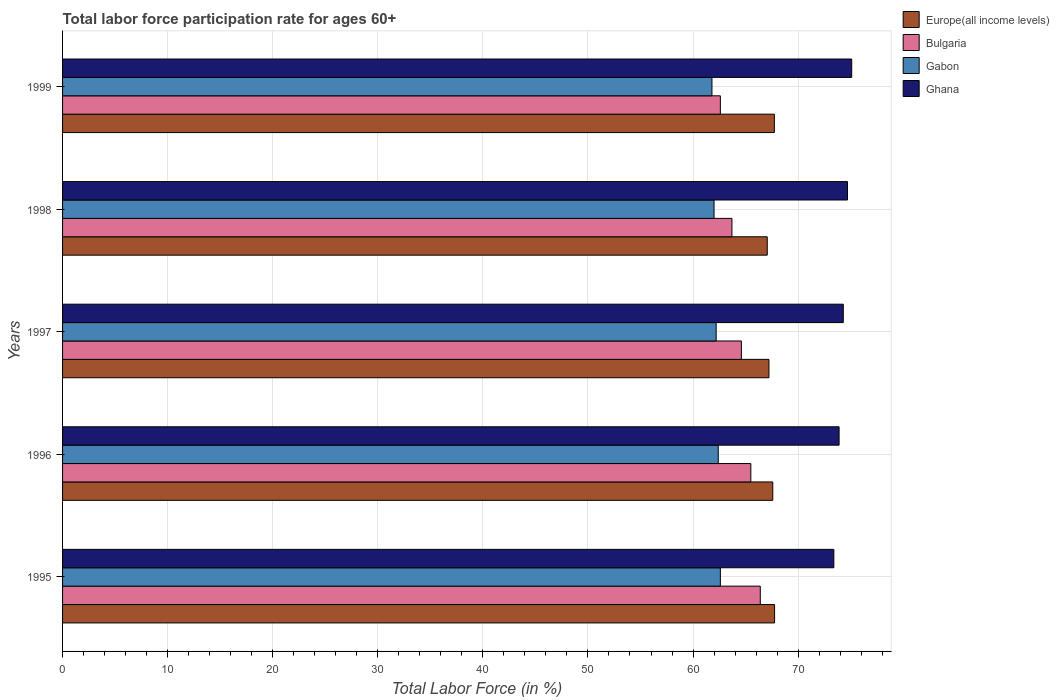How many different coloured bars are there?
Provide a succinct answer. 4. How many groups of bars are there?
Ensure brevity in your answer.  5. Are the number of bars per tick equal to the number of legend labels?
Your answer should be very brief. Yes. Are the number of bars on each tick of the Y-axis equal?
Provide a short and direct response. Yes. How many bars are there on the 2nd tick from the top?
Your response must be concise. 4. What is the labor force participation rate in Bulgaria in 1997?
Provide a short and direct response. 64.6. Across all years, what is the maximum labor force participation rate in Ghana?
Give a very brief answer. 75.1. Across all years, what is the minimum labor force participation rate in Gabon?
Provide a short and direct response. 61.8. What is the total labor force participation rate in Gabon in the graph?
Your answer should be compact. 311. What is the difference between the labor force participation rate in Ghana in 1997 and that in 1998?
Your answer should be very brief. -0.4. What is the difference between the labor force participation rate in Ghana in 1997 and the labor force participation rate in Bulgaria in 1999?
Your response must be concise. 11.7. What is the average labor force participation rate in Ghana per year?
Offer a terse response. 74.28. In the year 1999, what is the difference between the labor force participation rate in Europe(all income levels) and labor force participation rate in Ghana?
Give a very brief answer. -7.36. What is the ratio of the labor force participation rate in Bulgaria in 1995 to that in 1998?
Provide a short and direct response. 1.04. Is the labor force participation rate in Ghana in 1998 less than that in 1999?
Offer a terse response. Yes. Is the difference between the labor force participation rate in Europe(all income levels) in 1996 and 1998 greater than the difference between the labor force participation rate in Ghana in 1996 and 1998?
Provide a succinct answer. Yes. What is the difference between the highest and the second highest labor force participation rate in Europe(all income levels)?
Your response must be concise. 0.02. What is the difference between the highest and the lowest labor force participation rate in Gabon?
Keep it short and to the point. 0.8. In how many years, is the labor force participation rate in Ghana greater than the average labor force participation rate in Ghana taken over all years?
Ensure brevity in your answer.  3. Is it the case that in every year, the sum of the labor force participation rate in Ghana and labor force participation rate in Gabon is greater than the sum of labor force participation rate in Bulgaria and labor force participation rate in Europe(all income levels)?
Your answer should be very brief. No. What does the 1st bar from the top in 1997 represents?
Provide a short and direct response. Ghana. What does the 1st bar from the bottom in 1995 represents?
Keep it short and to the point. Europe(all income levels). Is it the case that in every year, the sum of the labor force participation rate in Ghana and labor force participation rate in Europe(all income levels) is greater than the labor force participation rate in Gabon?
Your answer should be compact. Yes. How many bars are there?
Provide a short and direct response. 20. Are all the bars in the graph horizontal?
Give a very brief answer. Yes. How many years are there in the graph?
Provide a succinct answer. 5. What is the difference between two consecutive major ticks on the X-axis?
Give a very brief answer. 10. Does the graph contain any zero values?
Make the answer very short. No. Does the graph contain grids?
Offer a terse response. Yes. Where does the legend appear in the graph?
Give a very brief answer. Top right. What is the title of the graph?
Offer a terse response. Total labor force participation rate for ages 60+. What is the label or title of the Y-axis?
Offer a terse response. Years. What is the Total Labor Force (in %) of Europe(all income levels) in 1995?
Keep it short and to the point. 67.76. What is the Total Labor Force (in %) in Bulgaria in 1995?
Keep it short and to the point. 66.4. What is the Total Labor Force (in %) of Gabon in 1995?
Your answer should be compact. 62.6. What is the Total Labor Force (in %) of Ghana in 1995?
Provide a succinct answer. 73.4. What is the Total Labor Force (in %) in Europe(all income levels) in 1996?
Provide a succinct answer. 67.59. What is the Total Labor Force (in %) of Bulgaria in 1996?
Your answer should be very brief. 65.5. What is the Total Labor Force (in %) in Gabon in 1996?
Ensure brevity in your answer.  62.4. What is the Total Labor Force (in %) in Ghana in 1996?
Provide a succinct answer. 73.9. What is the Total Labor Force (in %) of Europe(all income levels) in 1997?
Keep it short and to the point. 67.22. What is the Total Labor Force (in %) in Bulgaria in 1997?
Provide a short and direct response. 64.6. What is the Total Labor Force (in %) of Gabon in 1997?
Offer a very short reply. 62.2. What is the Total Labor Force (in %) in Ghana in 1997?
Provide a short and direct response. 74.3. What is the Total Labor Force (in %) of Europe(all income levels) in 1998?
Your response must be concise. 67.06. What is the Total Labor Force (in %) of Bulgaria in 1998?
Ensure brevity in your answer.  63.7. What is the Total Labor Force (in %) of Ghana in 1998?
Your response must be concise. 74.7. What is the Total Labor Force (in %) in Europe(all income levels) in 1999?
Provide a succinct answer. 67.74. What is the Total Labor Force (in %) of Bulgaria in 1999?
Keep it short and to the point. 62.6. What is the Total Labor Force (in %) of Gabon in 1999?
Offer a very short reply. 61.8. What is the Total Labor Force (in %) of Ghana in 1999?
Provide a short and direct response. 75.1. Across all years, what is the maximum Total Labor Force (in %) of Europe(all income levels)?
Your answer should be compact. 67.76. Across all years, what is the maximum Total Labor Force (in %) in Bulgaria?
Provide a succinct answer. 66.4. Across all years, what is the maximum Total Labor Force (in %) in Gabon?
Provide a succinct answer. 62.6. Across all years, what is the maximum Total Labor Force (in %) of Ghana?
Keep it short and to the point. 75.1. Across all years, what is the minimum Total Labor Force (in %) of Europe(all income levels)?
Give a very brief answer. 67.06. Across all years, what is the minimum Total Labor Force (in %) in Bulgaria?
Keep it short and to the point. 62.6. Across all years, what is the minimum Total Labor Force (in %) in Gabon?
Your answer should be very brief. 61.8. Across all years, what is the minimum Total Labor Force (in %) in Ghana?
Give a very brief answer. 73.4. What is the total Total Labor Force (in %) in Europe(all income levels) in the graph?
Your answer should be very brief. 337.38. What is the total Total Labor Force (in %) of Bulgaria in the graph?
Ensure brevity in your answer.  322.8. What is the total Total Labor Force (in %) in Gabon in the graph?
Give a very brief answer. 311. What is the total Total Labor Force (in %) of Ghana in the graph?
Provide a short and direct response. 371.4. What is the difference between the Total Labor Force (in %) of Europe(all income levels) in 1995 and that in 1996?
Keep it short and to the point. 0.17. What is the difference between the Total Labor Force (in %) of Bulgaria in 1995 and that in 1996?
Make the answer very short. 0.9. What is the difference between the Total Labor Force (in %) of Europe(all income levels) in 1995 and that in 1997?
Your response must be concise. 0.54. What is the difference between the Total Labor Force (in %) of Gabon in 1995 and that in 1997?
Offer a terse response. 0.4. What is the difference between the Total Labor Force (in %) of Ghana in 1995 and that in 1997?
Your answer should be very brief. -0.9. What is the difference between the Total Labor Force (in %) of Europe(all income levels) in 1995 and that in 1998?
Provide a succinct answer. 0.7. What is the difference between the Total Labor Force (in %) of Gabon in 1995 and that in 1998?
Offer a very short reply. 0.6. What is the difference between the Total Labor Force (in %) of Europe(all income levels) in 1995 and that in 1999?
Your response must be concise. 0.02. What is the difference between the Total Labor Force (in %) of Europe(all income levels) in 1996 and that in 1997?
Keep it short and to the point. 0.36. What is the difference between the Total Labor Force (in %) in Bulgaria in 1996 and that in 1997?
Ensure brevity in your answer.  0.9. What is the difference between the Total Labor Force (in %) in Gabon in 1996 and that in 1997?
Give a very brief answer. 0.2. What is the difference between the Total Labor Force (in %) of Ghana in 1996 and that in 1997?
Your response must be concise. -0.4. What is the difference between the Total Labor Force (in %) of Europe(all income levels) in 1996 and that in 1998?
Offer a terse response. 0.53. What is the difference between the Total Labor Force (in %) in Europe(all income levels) in 1996 and that in 1999?
Give a very brief answer. -0.15. What is the difference between the Total Labor Force (in %) in Ghana in 1996 and that in 1999?
Offer a terse response. -1.2. What is the difference between the Total Labor Force (in %) in Europe(all income levels) in 1997 and that in 1998?
Offer a terse response. 0.16. What is the difference between the Total Labor Force (in %) of Bulgaria in 1997 and that in 1998?
Offer a very short reply. 0.9. What is the difference between the Total Labor Force (in %) of Ghana in 1997 and that in 1998?
Your answer should be compact. -0.4. What is the difference between the Total Labor Force (in %) in Europe(all income levels) in 1997 and that in 1999?
Provide a succinct answer. -0.52. What is the difference between the Total Labor Force (in %) in Bulgaria in 1997 and that in 1999?
Offer a terse response. 2. What is the difference between the Total Labor Force (in %) of Europe(all income levels) in 1998 and that in 1999?
Offer a terse response. -0.68. What is the difference between the Total Labor Force (in %) of Bulgaria in 1998 and that in 1999?
Your response must be concise. 1.1. What is the difference between the Total Labor Force (in %) in Gabon in 1998 and that in 1999?
Your response must be concise. 0.2. What is the difference between the Total Labor Force (in %) of Europe(all income levels) in 1995 and the Total Labor Force (in %) of Bulgaria in 1996?
Provide a short and direct response. 2.26. What is the difference between the Total Labor Force (in %) in Europe(all income levels) in 1995 and the Total Labor Force (in %) in Gabon in 1996?
Provide a succinct answer. 5.36. What is the difference between the Total Labor Force (in %) in Europe(all income levels) in 1995 and the Total Labor Force (in %) in Ghana in 1996?
Your answer should be very brief. -6.14. What is the difference between the Total Labor Force (in %) of Bulgaria in 1995 and the Total Labor Force (in %) of Gabon in 1996?
Offer a very short reply. 4. What is the difference between the Total Labor Force (in %) in Gabon in 1995 and the Total Labor Force (in %) in Ghana in 1996?
Provide a succinct answer. -11.3. What is the difference between the Total Labor Force (in %) in Europe(all income levels) in 1995 and the Total Labor Force (in %) in Bulgaria in 1997?
Keep it short and to the point. 3.16. What is the difference between the Total Labor Force (in %) of Europe(all income levels) in 1995 and the Total Labor Force (in %) of Gabon in 1997?
Ensure brevity in your answer.  5.56. What is the difference between the Total Labor Force (in %) in Europe(all income levels) in 1995 and the Total Labor Force (in %) in Ghana in 1997?
Your answer should be compact. -6.54. What is the difference between the Total Labor Force (in %) in Gabon in 1995 and the Total Labor Force (in %) in Ghana in 1997?
Your response must be concise. -11.7. What is the difference between the Total Labor Force (in %) of Europe(all income levels) in 1995 and the Total Labor Force (in %) of Bulgaria in 1998?
Your answer should be very brief. 4.06. What is the difference between the Total Labor Force (in %) of Europe(all income levels) in 1995 and the Total Labor Force (in %) of Gabon in 1998?
Your response must be concise. 5.76. What is the difference between the Total Labor Force (in %) of Europe(all income levels) in 1995 and the Total Labor Force (in %) of Ghana in 1998?
Offer a very short reply. -6.94. What is the difference between the Total Labor Force (in %) of Bulgaria in 1995 and the Total Labor Force (in %) of Gabon in 1998?
Make the answer very short. 4.4. What is the difference between the Total Labor Force (in %) in Bulgaria in 1995 and the Total Labor Force (in %) in Ghana in 1998?
Your answer should be very brief. -8.3. What is the difference between the Total Labor Force (in %) of Europe(all income levels) in 1995 and the Total Labor Force (in %) of Bulgaria in 1999?
Provide a succinct answer. 5.16. What is the difference between the Total Labor Force (in %) in Europe(all income levels) in 1995 and the Total Labor Force (in %) in Gabon in 1999?
Your response must be concise. 5.96. What is the difference between the Total Labor Force (in %) of Europe(all income levels) in 1995 and the Total Labor Force (in %) of Ghana in 1999?
Provide a short and direct response. -7.34. What is the difference between the Total Labor Force (in %) of Bulgaria in 1995 and the Total Labor Force (in %) of Ghana in 1999?
Your answer should be very brief. -8.7. What is the difference between the Total Labor Force (in %) in Gabon in 1995 and the Total Labor Force (in %) in Ghana in 1999?
Offer a very short reply. -12.5. What is the difference between the Total Labor Force (in %) in Europe(all income levels) in 1996 and the Total Labor Force (in %) in Bulgaria in 1997?
Your response must be concise. 2.99. What is the difference between the Total Labor Force (in %) in Europe(all income levels) in 1996 and the Total Labor Force (in %) in Gabon in 1997?
Provide a succinct answer. 5.39. What is the difference between the Total Labor Force (in %) of Europe(all income levels) in 1996 and the Total Labor Force (in %) of Ghana in 1997?
Ensure brevity in your answer.  -6.71. What is the difference between the Total Labor Force (in %) in Bulgaria in 1996 and the Total Labor Force (in %) in Ghana in 1997?
Give a very brief answer. -8.8. What is the difference between the Total Labor Force (in %) of Europe(all income levels) in 1996 and the Total Labor Force (in %) of Bulgaria in 1998?
Make the answer very short. 3.89. What is the difference between the Total Labor Force (in %) of Europe(all income levels) in 1996 and the Total Labor Force (in %) of Gabon in 1998?
Provide a succinct answer. 5.59. What is the difference between the Total Labor Force (in %) in Europe(all income levels) in 1996 and the Total Labor Force (in %) in Ghana in 1998?
Offer a very short reply. -7.11. What is the difference between the Total Labor Force (in %) in Bulgaria in 1996 and the Total Labor Force (in %) in Ghana in 1998?
Give a very brief answer. -9.2. What is the difference between the Total Labor Force (in %) in Europe(all income levels) in 1996 and the Total Labor Force (in %) in Bulgaria in 1999?
Your answer should be compact. 4.99. What is the difference between the Total Labor Force (in %) of Europe(all income levels) in 1996 and the Total Labor Force (in %) of Gabon in 1999?
Ensure brevity in your answer.  5.79. What is the difference between the Total Labor Force (in %) in Europe(all income levels) in 1996 and the Total Labor Force (in %) in Ghana in 1999?
Give a very brief answer. -7.51. What is the difference between the Total Labor Force (in %) in Bulgaria in 1996 and the Total Labor Force (in %) in Gabon in 1999?
Offer a terse response. 3.7. What is the difference between the Total Labor Force (in %) in Europe(all income levels) in 1997 and the Total Labor Force (in %) in Bulgaria in 1998?
Your answer should be very brief. 3.52. What is the difference between the Total Labor Force (in %) in Europe(all income levels) in 1997 and the Total Labor Force (in %) in Gabon in 1998?
Provide a succinct answer. 5.22. What is the difference between the Total Labor Force (in %) in Europe(all income levels) in 1997 and the Total Labor Force (in %) in Ghana in 1998?
Your answer should be very brief. -7.48. What is the difference between the Total Labor Force (in %) in Bulgaria in 1997 and the Total Labor Force (in %) in Gabon in 1998?
Provide a short and direct response. 2.6. What is the difference between the Total Labor Force (in %) of Bulgaria in 1997 and the Total Labor Force (in %) of Ghana in 1998?
Make the answer very short. -10.1. What is the difference between the Total Labor Force (in %) of Gabon in 1997 and the Total Labor Force (in %) of Ghana in 1998?
Provide a short and direct response. -12.5. What is the difference between the Total Labor Force (in %) of Europe(all income levels) in 1997 and the Total Labor Force (in %) of Bulgaria in 1999?
Ensure brevity in your answer.  4.62. What is the difference between the Total Labor Force (in %) in Europe(all income levels) in 1997 and the Total Labor Force (in %) in Gabon in 1999?
Your response must be concise. 5.42. What is the difference between the Total Labor Force (in %) in Europe(all income levels) in 1997 and the Total Labor Force (in %) in Ghana in 1999?
Keep it short and to the point. -7.88. What is the difference between the Total Labor Force (in %) of Bulgaria in 1997 and the Total Labor Force (in %) of Gabon in 1999?
Make the answer very short. 2.8. What is the difference between the Total Labor Force (in %) of Bulgaria in 1997 and the Total Labor Force (in %) of Ghana in 1999?
Ensure brevity in your answer.  -10.5. What is the difference between the Total Labor Force (in %) in Europe(all income levels) in 1998 and the Total Labor Force (in %) in Bulgaria in 1999?
Provide a short and direct response. 4.46. What is the difference between the Total Labor Force (in %) in Europe(all income levels) in 1998 and the Total Labor Force (in %) in Gabon in 1999?
Keep it short and to the point. 5.26. What is the difference between the Total Labor Force (in %) of Europe(all income levels) in 1998 and the Total Labor Force (in %) of Ghana in 1999?
Make the answer very short. -8.04. What is the difference between the Total Labor Force (in %) of Bulgaria in 1998 and the Total Labor Force (in %) of Ghana in 1999?
Keep it short and to the point. -11.4. What is the difference between the Total Labor Force (in %) in Gabon in 1998 and the Total Labor Force (in %) in Ghana in 1999?
Provide a succinct answer. -13.1. What is the average Total Labor Force (in %) of Europe(all income levels) per year?
Keep it short and to the point. 67.48. What is the average Total Labor Force (in %) of Bulgaria per year?
Your answer should be very brief. 64.56. What is the average Total Labor Force (in %) in Gabon per year?
Provide a succinct answer. 62.2. What is the average Total Labor Force (in %) of Ghana per year?
Your response must be concise. 74.28. In the year 1995, what is the difference between the Total Labor Force (in %) in Europe(all income levels) and Total Labor Force (in %) in Bulgaria?
Offer a very short reply. 1.36. In the year 1995, what is the difference between the Total Labor Force (in %) of Europe(all income levels) and Total Labor Force (in %) of Gabon?
Provide a short and direct response. 5.16. In the year 1995, what is the difference between the Total Labor Force (in %) of Europe(all income levels) and Total Labor Force (in %) of Ghana?
Offer a terse response. -5.64. In the year 1995, what is the difference between the Total Labor Force (in %) of Bulgaria and Total Labor Force (in %) of Gabon?
Your response must be concise. 3.8. In the year 1995, what is the difference between the Total Labor Force (in %) of Bulgaria and Total Labor Force (in %) of Ghana?
Provide a succinct answer. -7. In the year 1996, what is the difference between the Total Labor Force (in %) of Europe(all income levels) and Total Labor Force (in %) of Bulgaria?
Offer a terse response. 2.09. In the year 1996, what is the difference between the Total Labor Force (in %) in Europe(all income levels) and Total Labor Force (in %) in Gabon?
Provide a short and direct response. 5.19. In the year 1996, what is the difference between the Total Labor Force (in %) in Europe(all income levels) and Total Labor Force (in %) in Ghana?
Keep it short and to the point. -6.31. In the year 1996, what is the difference between the Total Labor Force (in %) in Bulgaria and Total Labor Force (in %) in Ghana?
Offer a terse response. -8.4. In the year 1996, what is the difference between the Total Labor Force (in %) in Gabon and Total Labor Force (in %) in Ghana?
Your answer should be very brief. -11.5. In the year 1997, what is the difference between the Total Labor Force (in %) of Europe(all income levels) and Total Labor Force (in %) of Bulgaria?
Provide a short and direct response. 2.62. In the year 1997, what is the difference between the Total Labor Force (in %) of Europe(all income levels) and Total Labor Force (in %) of Gabon?
Keep it short and to the point. 5.02. In the year 1997, what is the difference between the Total Labor Force (in %) of Europe(all income levels) and Total Labor Force (in %) of Ghana?
Provide a short and direct response. -7.08. In the year 1997, what is the difference between the Total Labor Force (in %) of Bulgaria and Total Labor Force (in %) of Gabon?
Offer a very short reply. 2.4. In the year 1998, what is the difference between the Total Labor Force (in %) of Europe(all income levels) and Total Labor Force (in %) of Bulgaria?
Your answer should be compact. 3.36. In the year 1998, what is the difference between the Total Labor Force (in %) in Europe(all income levels) and Total Labor Force (in %) in Gabon?
Keep it short and to the point. 5.06. In the year 1998, what is the difference between the Total Labor Force (in %) of Europe(all income levels) and Total Labor Force (in %) of Ghana?
Your answer should be very brief. -7.64. In the year 1998, what is the difference between the Total Labor Force (in %) of Bulgaria and Total Labor Force (in %) of Gabon?
Offer a terse response. 1.7. In the year 1998, what is the difference between the Total Labor Force (in %) in Bulgaria and Total Labor Force (in %) in Ghana?
Make the answer very short. -11. In the year 1998, what is the difference between the Total Labor Force (in %) in Gabon and Total Labor Force (in %) in Ghana?
Make the answer very short. -12.7. In the year 1999, what is the difference between the Total Labor Force (in %) of Europe(all income levels) and Total Labor Force (in %) of Bulgaria?
Provide a short and direct response. 5.14. In the year 1999, what is the difference between the Total Labor Force (in %) in Europe(all income levels) and Total Labor Force (in %) in Gabon?
Give a very brief answer. 5.94. In the year 1999, what is the difference between the Total Labor Force (in %) in Europe(all income levels) and Total Labor Force (in %) in Ghana?
Keep it short and to the point. -7.36. In the year 1999, what is the difference between the Total Labor Force (in %) in Bulgaria and Total Labor Force (in %) in Gabon?
Your answer should be compact. 0.8. In the year 1999, what is the difference between the Total Labor Force (in %) of Bulgaria and Total Labor Force (in %) of Ghana?
Offer a terse response. -12.5. In the year 1999, what is the difference between the Total Labor Force (in %) of Gabon and Total Labor Force (in %) of Ghana?
Offer a terse response. -13.3. What is the ratio of the Total Labor Force (in %) of Europe(all income levels) in 1995 to that in 1996?
Offer a terse response. 1. What is the ratio of the Total Labor Force (in %) of Bulgaria in 1995 to that in 1996?
Make the answer very short. 1.01. What is the ratio of the Total Labor Force (in %) in Ghana in 1995 to that in 1996?
Keep it short and to the point. 0.99. What is the ratio of the Total Labor Force (in %) in Europe(all income levels) in 1995 to that in 1997?
Your response must be concise. 1.01. What is the ratio of the Total Labor Force (in %) of Bulgaria in 1995 to that in 1997?
Provide a short and direct response. 1.03. What is the ratio of the Total Labor Force (in %) in Gabon in 1995 to that in 1997?
Give a very brief answer. 1.01. What is the ratio of the Total Labor Force (in %) of Ghana in 1995 to that in 1997?
Your answer should be compact. 0.99. What is the ratio of the Total Labor Force (in %) of Europe(all income levels) in 1995 to that in 1998?
Keep it short and to the point. 1.01. What is the ratio of the Total Labor Force (in %) of Bulgaria in 1995 to that in 1998?
Your response must be concise. 1.04. What is the ratio of the Total Labor Force (in %) in Gabon in 1995 to that in 1998?
Provide a short and direct response. 1.01. What is the ratio of the Total Labor Force (in %) of Ghana in 1995 to that in 1998?
Your answer should be very brief. 0.98. What is the ratio of the Total Labor Force (in %) in Europe(all income levels) in 1995 to that in 1999?
Provide a succinct answer. 1. What is the ratio of the Total Labor Force (in %) in Bulgaria in 1995 to that in 1999?
Keep it short and to the point. 1.06. What is the ratio of the Total Labor Force (in %) in Gabon in 1995 to that in 1999?
Your answer should be compact. 1.01. What is the ratio of the Total Labor Force (in %) in Ghana in 1995 to that in 1999?
Offer a terse response. 0.98. What is the ratio of the Total Labor Force (in %) in Europe(all income levels) in 1996 to that in 1997?
Your answer should be compact. 1.01. What is the ratio of the Total Labor Force (in %) in Bulgaria in 1996 to that in 1997?
Provide a succinct answer. 1.01. What is the ratio of the Total Labor Force (in %) of Gabon in 1996 to that in 1997?
Provide a short and direct response. 1. What is the ratio of the Total Labor Force (in %) of Bulgaria in 1996 to that in 1998?
Your answer should be compact. 1.03. What is the ratio of the Total Labor Force (in %) in Gabon in 1996 to that in 1998?
Offer a terse response. 1.01. What is the ratio of the Total Labor Force (in %) of Ghana in 1996 to that in 1998?
Offer a terse response. 0.99. What is the ratio of the Total Labor Force (in %) of Europe(all income levels) in 1996 to that in 1999?
Your answer should be very brief. 1. What is the ratio of the Total Labor Force (in %) in Bulgaria in 1996 to that in 1999?
Make the answer very short. 1.05. What is the ratio of the Total Labor Force (in %) of Gabon in 1996 to that in 1999?
Make the answer very short. 1.01. What is the ratio of the Total Labor Force (in %) of Ghana in 1996 to that in 1999?
Provide a succinct answer. 0.98. What is the ratio of the Total Labor Force (in %) in Bulgaria in 1997 to that in 1998?
Your response must be concise. 1.01. What is the ratio of the Total Labor Force (in %) of Gabon in 1997 to that in 1998?
Provide a succinct answer. 1. What is the ratio of the Total Labor Force (in %) of Ghana in 1997 to that in 1998?
Make the answer very short. 0.99. What is the ratio of the Total Labor Force (in %) in Bulgaria in 1997 to that in 1999?
Your answer should be compact. 1.03. What is the ratio of the Total Labor Force (in %) of Gabon in 1997 to that in 1999?
Offer a very short reply. 1.01. What is the ratio of the Total Labor Force (in %) of Ghana in 1997 to that in 1999?
Your response must be concise. 0.99. What is the ratio of the Total Labor Force (in %) in Bulgaria in 1998 to that in 1999?
Your response must be concise. 1.02. What is the ratio of the Total Labor Force (in %) in Gabon in 1998 to that in 1999?
Offer a very short reply. 1. What is the difference between the highest and the second highest Total Labor Force (in %) of Europe(all income levels)?
Provide a short and direct response. 0.02. What is the difference between the highest and the second highest Total Labor Force (in %) in Bulgaria?
Your answer should be very brief. 0.9. What is the difference between the highest and the second highest Total Labor Force (in %) in Gabon?
Give a very brief answer. 0.2. What is the difference between the highest and the lowest Total Labor Force (in %) of Europe(all income levels)?
Make the answer very short. 0.7. What is the difference between the highest and the lowest Total Labor Force (in %) in Bulgaria?
Keep it short and to the point. 3.8. What is the difference between the highest and the lowest Total Labor Force (in %) of Gabon?
Provide a short and direct response. 0.8. 